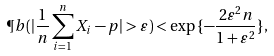<formula> <loc_0><loc_0><loc_500><loc_500>\P b ( | \frac { 1 } { n } \sum _ { i = 1 } ^ { n } X _ { i } - p | > \varepsilon ) < \exp { \{ - \frac { 2 \varepsilon ^ { 2 } n } { 1 + \varepsilon ^ { 2 } } \} } ,</formula> 